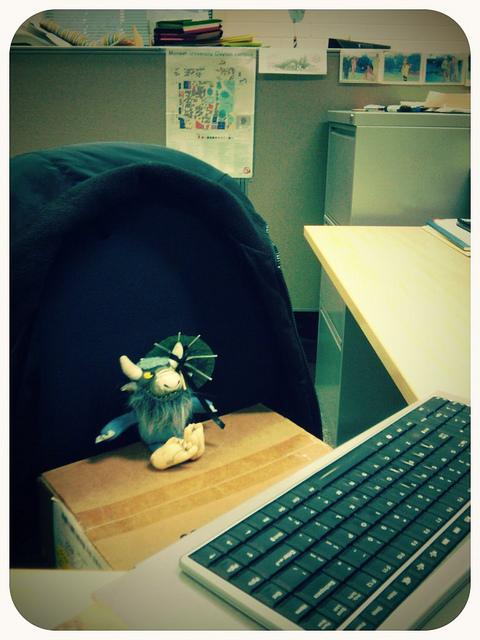Why does the cow have an umbrella?
Answer briefly. Decoration. What color is the filing cabinet?
Give a very brief answer. Gray. What color is the keyboard?
Be succinct. Black. 